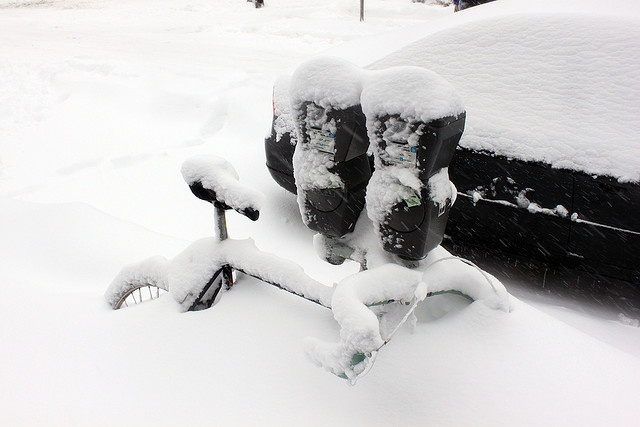Describe the objects in this image and their specific colors. I can see car in white, black, gray, lightgray, and darkgray tones, bicycle in white, lightgray, darkgray, black, and gray tones, parking meter in white, lightgray, black, darkgray, and gray tones, and parking meter in white, black, lightgray, darkgray, and gray tones in this image. 